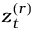<formula> <loc_0><loc_0><loc_500><loc_500>z _ { t } ^ { ( r ) }</formula> 